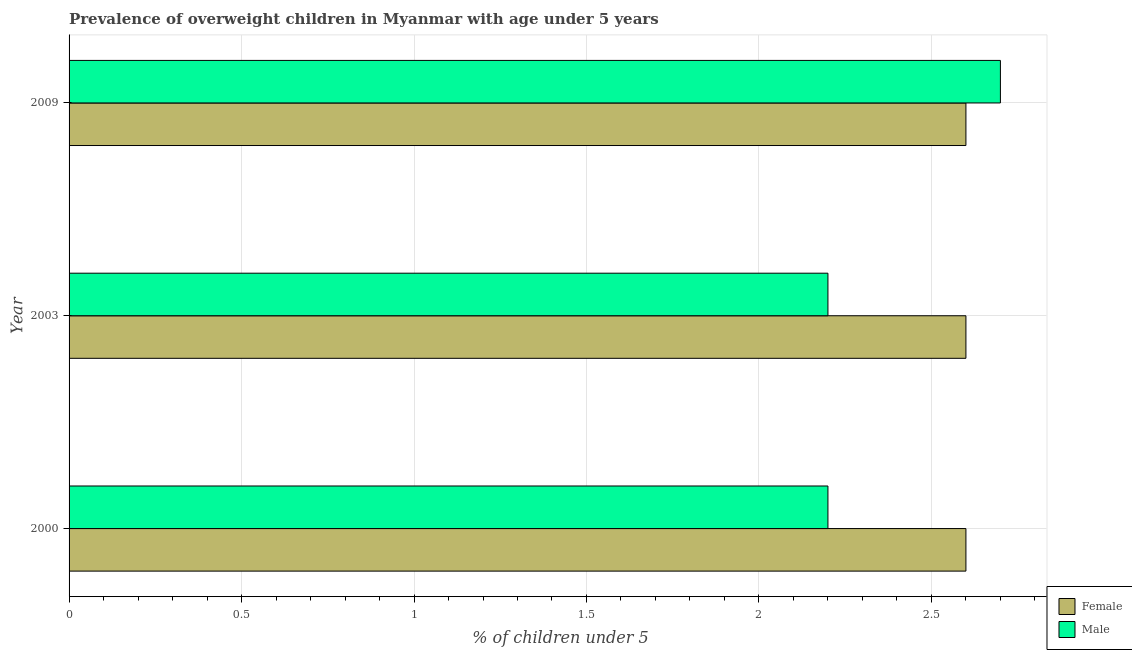How many different coloured bars are there?
Ensure brevity in your answer.  2. Are the number of bars on each tick of the Y-axis equal?
Make the answer very short. Yes. What is the label of the 1st group of bars from the top?
Provide a short and direct response. 2009. In how many cases, is the number of bars for a given year not equal to the number of legend labels?
Your answer should be compact. 0. What is the percentage of obese male children in 2000?
Offer a terse response. 2.2. Across all years, what is the maximum percentage of obese female children?
Provide a short and direct response. 2.6. Across all years, what is the minimum percentage of obese female children?
Your answer should be very brief. 2.6. What is the total percentage of obese female children in the graph?
Your answer should be very brief. 7.8. What is the difference between the percentage of obese female children in 2000 and the percentage of obese male children in 2009?
Your response must be concise. -0.1. What is the average percentage of obese male children per year?
Make the answer very short. 2.37. What is the ratio of the percentage of obese female children in 2003 to that in 2009?
Offer a terse response. 1. What is the difference between the highest and the second highest percentage of obese male children?
Offer a very short reply. 0.5. In how many years, is the percentage of obese female children greater than the average percentage of obese female children taken over all years?
Your response must be concise. 0. What does the 1st bar from the top in 2000 represents?
Make the answer very short. Male. What does the 1st bar from the bottom in 2000 represents?
Provide a succinct answer. Female. Are all the bars in the graph horizontal?
Offer a terse response. Yes. What is the difference between two consecutive major ticks on the X-axis?
Provide a short and direct response. 0.5. Are the values on the major ticks of X-axis written in scientific E-notation?
Your answer should be very brief. No. Does the graph contain any zero values?
Your answer should be compact. No. How are the legend labels stacked?
Your response must be concise. Vertical. What is the title of the graph?
Your answer should be very brief. Prevalence of overweight children in Myanmar with age under 5 years. Does "Females" appear as one of the legend labels in the graph?
Your answer should be very brief. No. What is the label or title of the X-axis?
Keep it short and to the point.  % of children under 5. What is the label or title of the Y-axis?
Offer a very short reply. Year. What is the  % of children under 5 in Female in 2000?
Offer a very short reply. 2.6. What is the  % of children under 5 in Male in 2000?
Offer a very short reply. 2.2. What is the  % of children under 5 of Female in 2003?
Offer a terse response. 2.6. What is the  % of children under 5 in Male in 2003?
Offer a terse response. 2.2. What is the  % of children under 5 in Female in 2009?
Your response must be concise. 2.6. What is the  % of children under 5 of Male in 2009?
Offer a terse response. 2.7. Across all years, what is the maximum  % of children under 5 of Female?
Offer a very short reply. 2.6. Across all years, what is the maximum  % of children under 5 of Male?
Keep it short and to the point. 2.7. Across all years, what is the minimum  % of children under 5 in Female?
Your answer should be very brief. 2.6. Across all years, what is the minimum  % of children under 5 of Male?
Your response must be concise. 2.2. What is the total  % of children under 5 in Female in the graph?
Give a very brief answer. 7.8. What is the difference between the  % of children under 5 of Male in 2000 and that in 2003?
Your answer should be very brief. 0. What is the difference between the  % of children under 5 of Male in 2000 and that in 2009?
Offer a very short reply. -0.5. What is the difference between the  % of children under 5 in Male in 2003 and that in 2009?
Provide a succinct answer. -0.5. What is the difference between the  % of children under 5 of Female in 2003 and the  % of children under 5 of Male in 2009?
Your answer should be very brief. -0.1. What is the average  % of children under 5 of Female per year?
Offer a very short reply. 2.6. What is the average  % of children under 5 in Male per year?
Provide a short and direct response. 2.37. In the year 2003, what is the difference between the  % of children under 5 of Female and  % of children under 5 of Male?
Your answer should be very brief. 0.4. What is the ratio of the  % of children under 5 of Female in 2000 to that in 2003?
Provide a short and direct response. 1. What is the ratio of the  % of children under 5 of Female in 2000 to that in 2009?
Keep it short and to the point. 1. What is the ratio of the  % of children under 5 of Male in 2000 to that in 2009?
Give a very brief answer. 0.81. What is the ratio of the  % of children under 5 of Female in 2003 to that in 2009?
Keep it short and to the point. 1. What is the ratio of the  % of children under 5 of Male in 2003 to that in 2009?
Your answer should be compact. 0.81. What is the difference between the highest and the second highest  % of children under 5 in Female?
Provide a short and direct response. 0. What is the difference between the highest and the lowest  % of children under 5 in Female?
Keep it short and to the point. 0. What is the difference between the highest and the lowest  % of children under 5 in Male?
Keep it short and to the point. 0.5. 